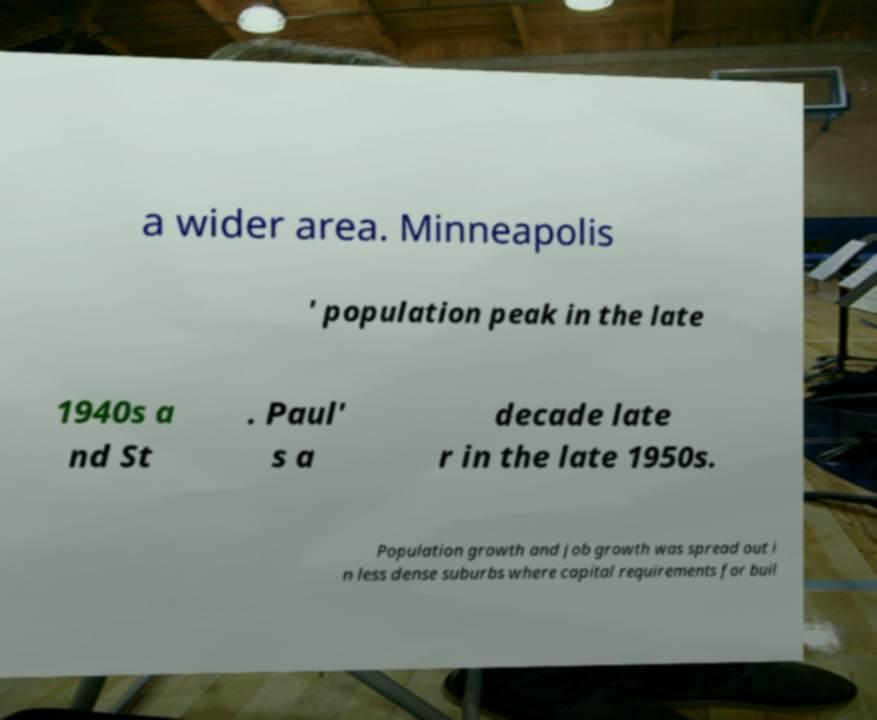Can you accurately transcribe the text from the provided image for me? a wider area. Minneapolis ' population peak in the late 1940s a nd St . Paul' s a decade late r in the late 1950s. Population growth and job growth was spread out i n less dense suburbs where capital requirements for buil 